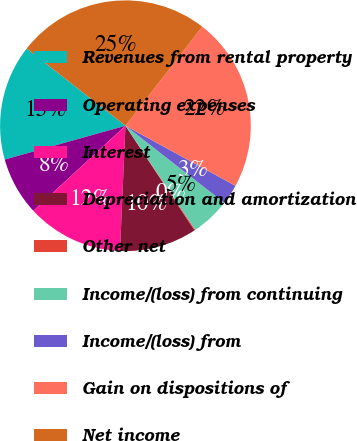<chart> <loc_0><loc_0><loc_500><loc_500><pie_chart><fcel>Revenues from rental property<fcel>Operating expenses<fcel>Interest<fcel>Depreciation and amortization<fcel>Other net<fcel>Income/(loss) from continuing<fcel>Income/(loss) from<fcel>Gain on dispositions of<fcel>Net income<nl><fcel>14.91%<fcel>7.52%<fcel>12.44%<fcel>9.98%<fcel>0.12%<fcel>5.05%<fcel>2.59%<fcel>22.46%<fcel>24.93%<nl></chart> 